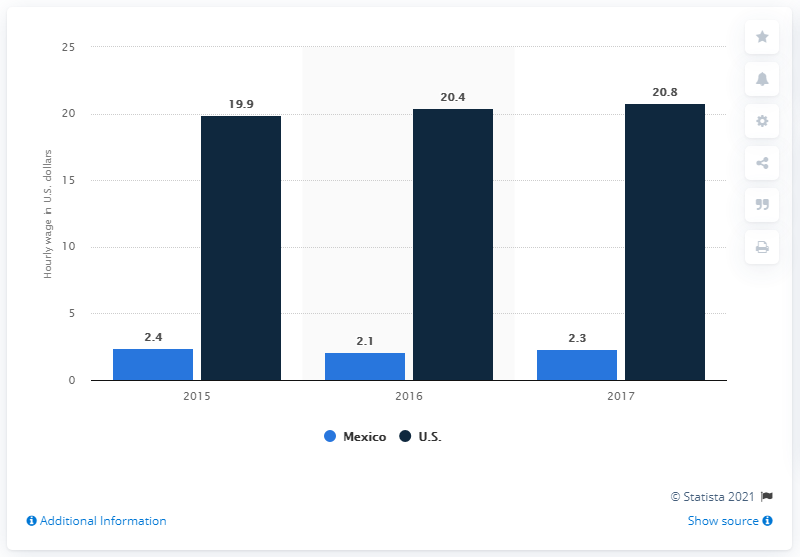Specify some key components in this picture. In June 2017, the average hourly wage for a manufacturing worker in Mexico was 2.3 U.S. dollars. In June 2017, the average hourly wage in the United States was $20.80. 